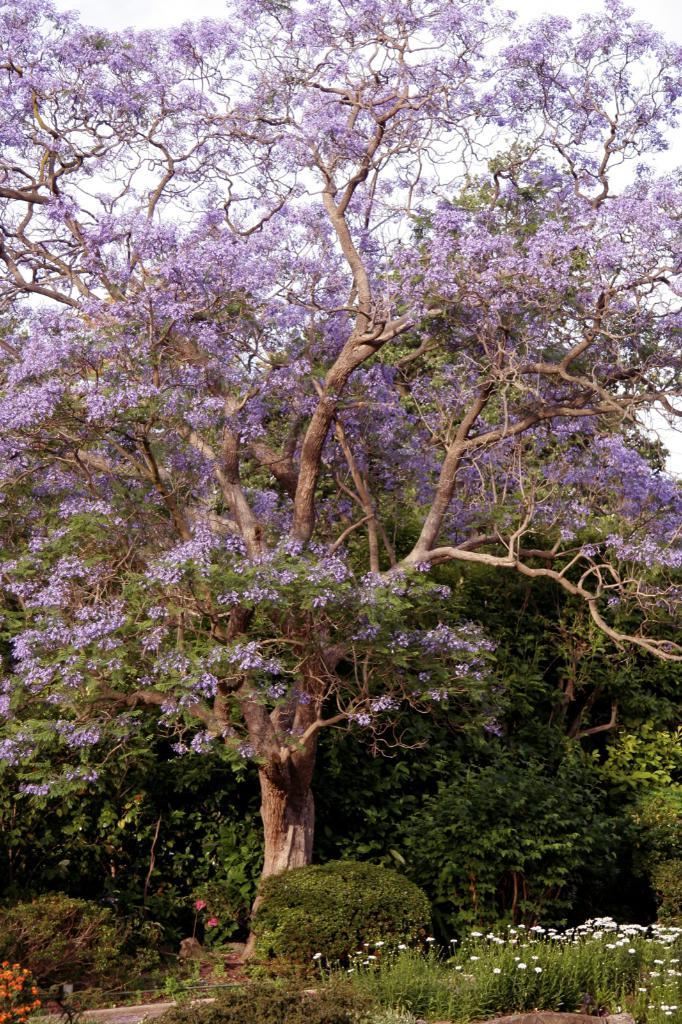What type of vegetation can be seen in the image? There are trees, plants, and flowers in the image. Can you describe the background of the image? The sky is visible behind the trees in the image. What is the primary focus of the image? The primary focus of the image is the vegetation, including trees, plants, and flowers. What type of oatmeal is being prepared in the image? There is no oatmeal present in the image; it features trees, plants, flowers, and the sky. 